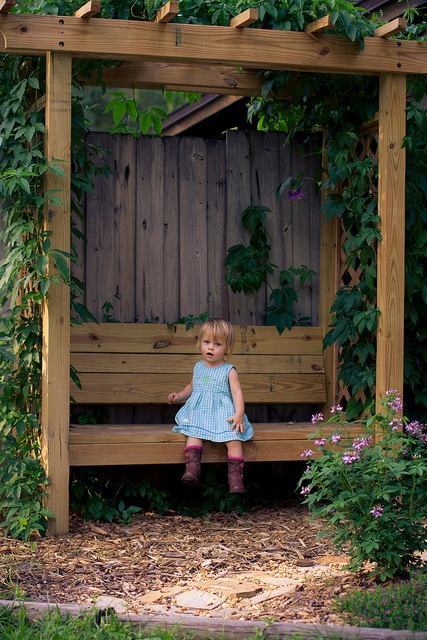Describe the objects in this image and their specific colors. I can see bench in tan, gray, and black tones and people in tan, lightblue, brown, and black tones in this image. 